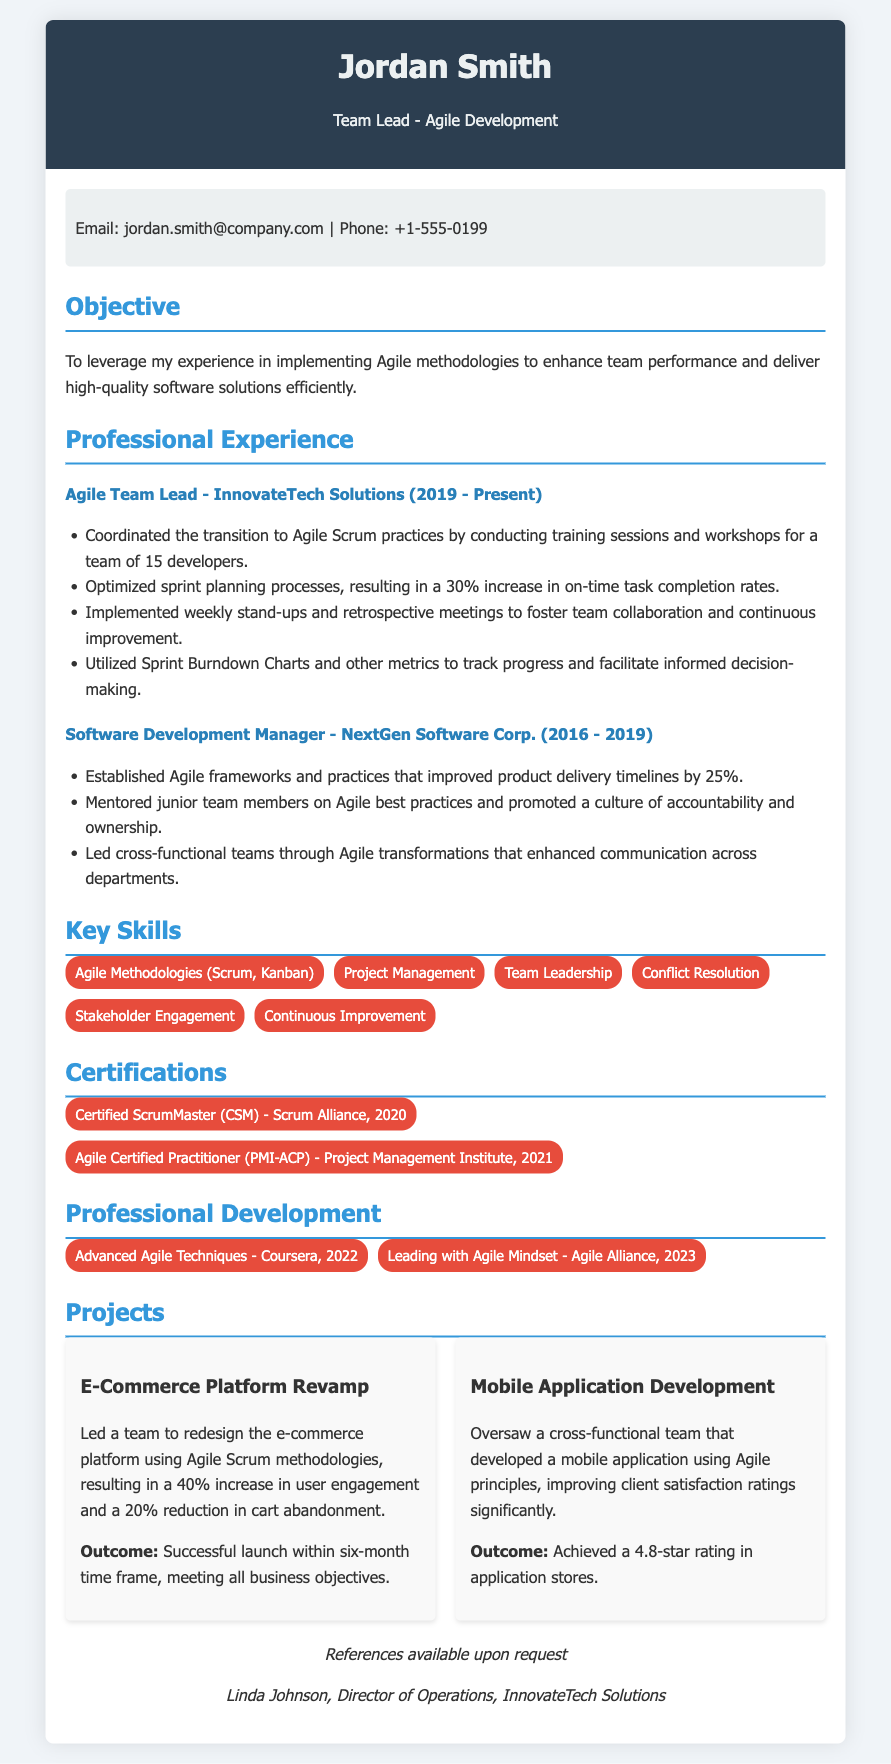What is the name of the candidate? The name of the candidate is presented prominently at the top of the CV.
Answer: Jordan Smith What is the candidate's current job title? The current job title is listed beneath the candidate's name.
Answer: Team Lead - Agile Development Which company does the candidate work for currently? The name of the current employer is mentioned in the professional experience section.
Answer: InnovateTech Solutions How much did the candidate improve on-time task completion rates? The improved on-time task completion rates percentage is stated clearly in one of the responsibilities listed.
Answer: 30% What are the years of experience at NextGen Software Corp.? The time spent at NextGen Software Corp. is stated alongside the job title and company name.
Answer: 2016 - 2019 Which Agile certification did the candidate earn in 2020? The certification information is listed under the certifications section of the CV.
Answer: Certified ScrumMaster (CSM) What percentage increase in user engagement was achieved in the e-commerce platform project? This metric is provided in the outcomes of the project description.
Answer: 40% What skill emphasizes conflict management? The skills section highlights various skills including one relevant to managing conflicts.
Answer: Conflict Resolution What is the highest star rating achieved for the mobile application? The star rating is provided in the project outcomes section related to the mobile application.
Answer: 4.8-star rating What is the name of the reference provided in the CV? The reference is mentioned at the end of the document.
Answer: Linda Johnson 